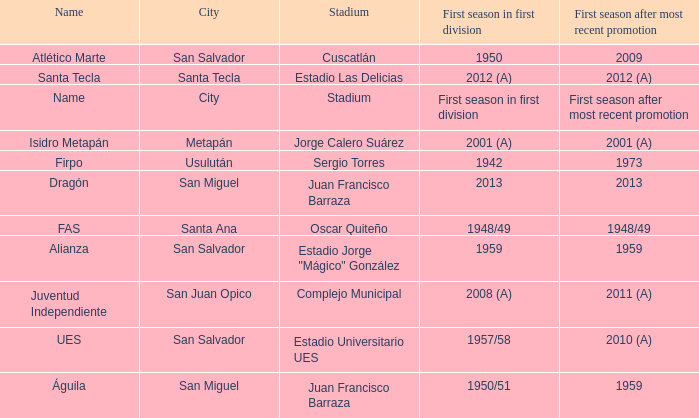When was Alianza's first season in first division with a promotion after 1959? 1959.0. 